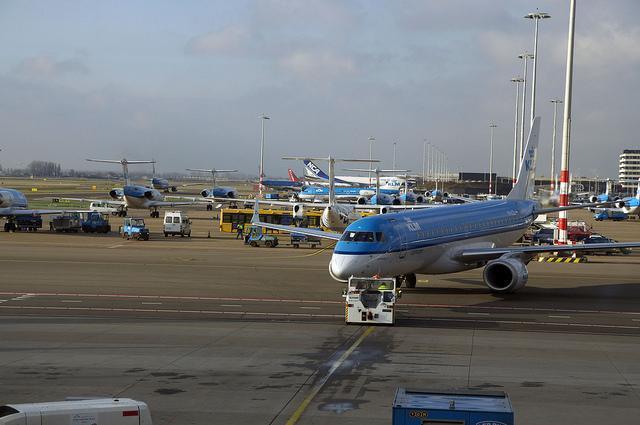What is the circular object under the wing?
Choose the right answer and clarify with the format: 'Answer: answer
Rationale: rationale.'
Options: Aileron, jet engine, compartment, trash can. Answer: jet engine.
Rationale: A jet engine is under the wing. 